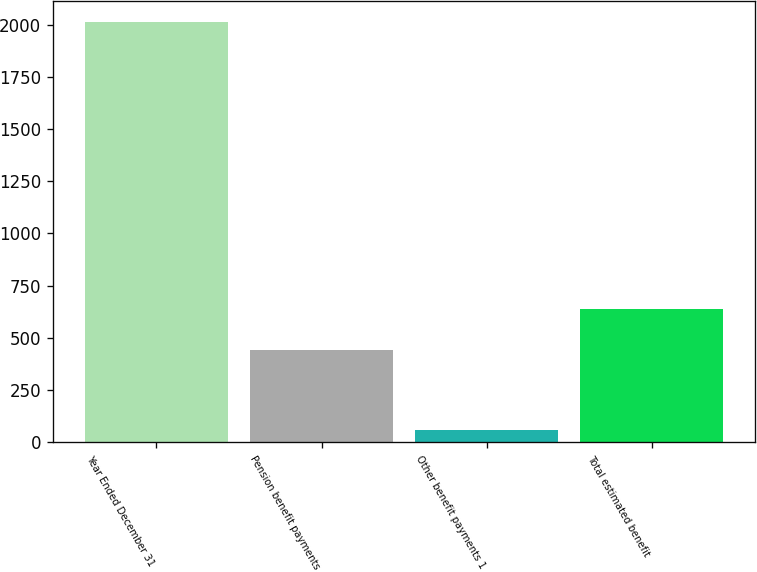<chart> <loc_0><loc_0><loc_500><loc_500><bar_chart><fcel>Year Ended December 31<fcel>Pension benefit payments<fcel>Other benefit payments 1<fcel>Total estimated benefit<nl><fcel>2012<fcel>442<fcel>59<fcel>637.3<nl></chart> 